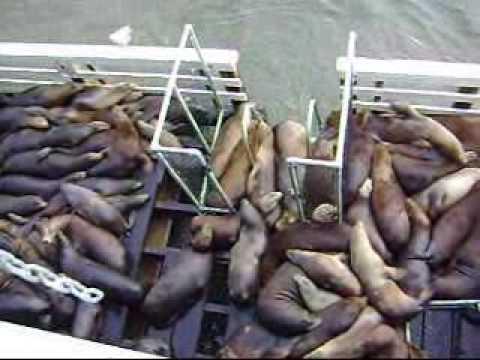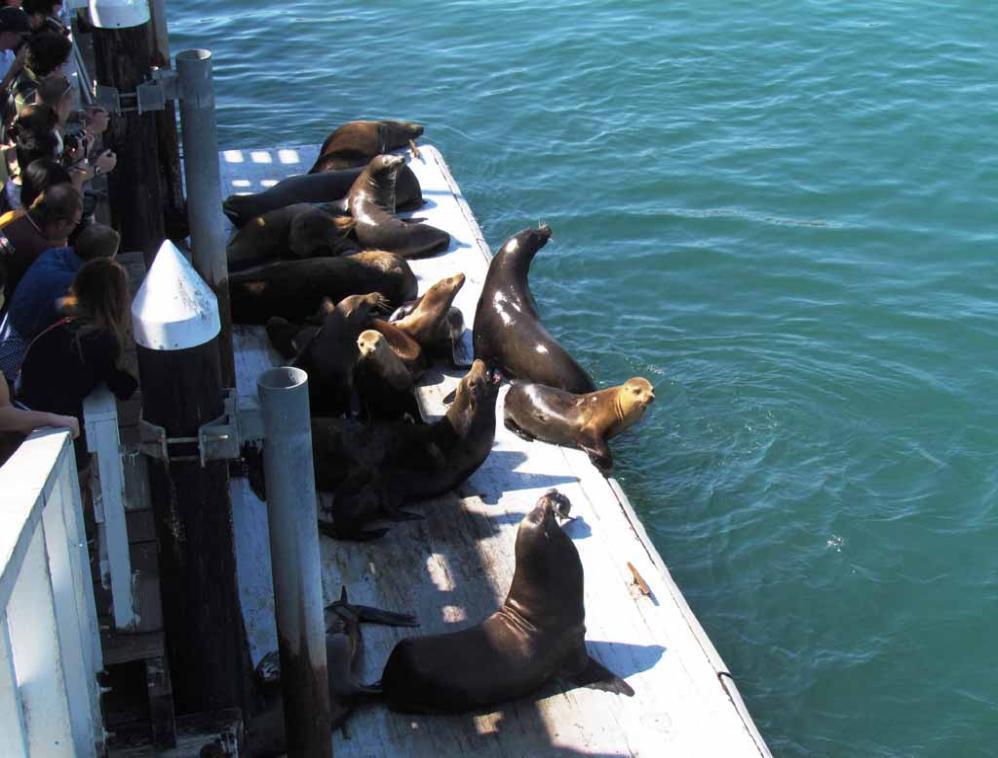The first image is the image on the left, the second image is the image on the right. Considering the images on both sides, is "The left image shows at least one seal balanced on a cross beam near vertical poles in water beneath a pier." valid? Answer yes or no. No. 